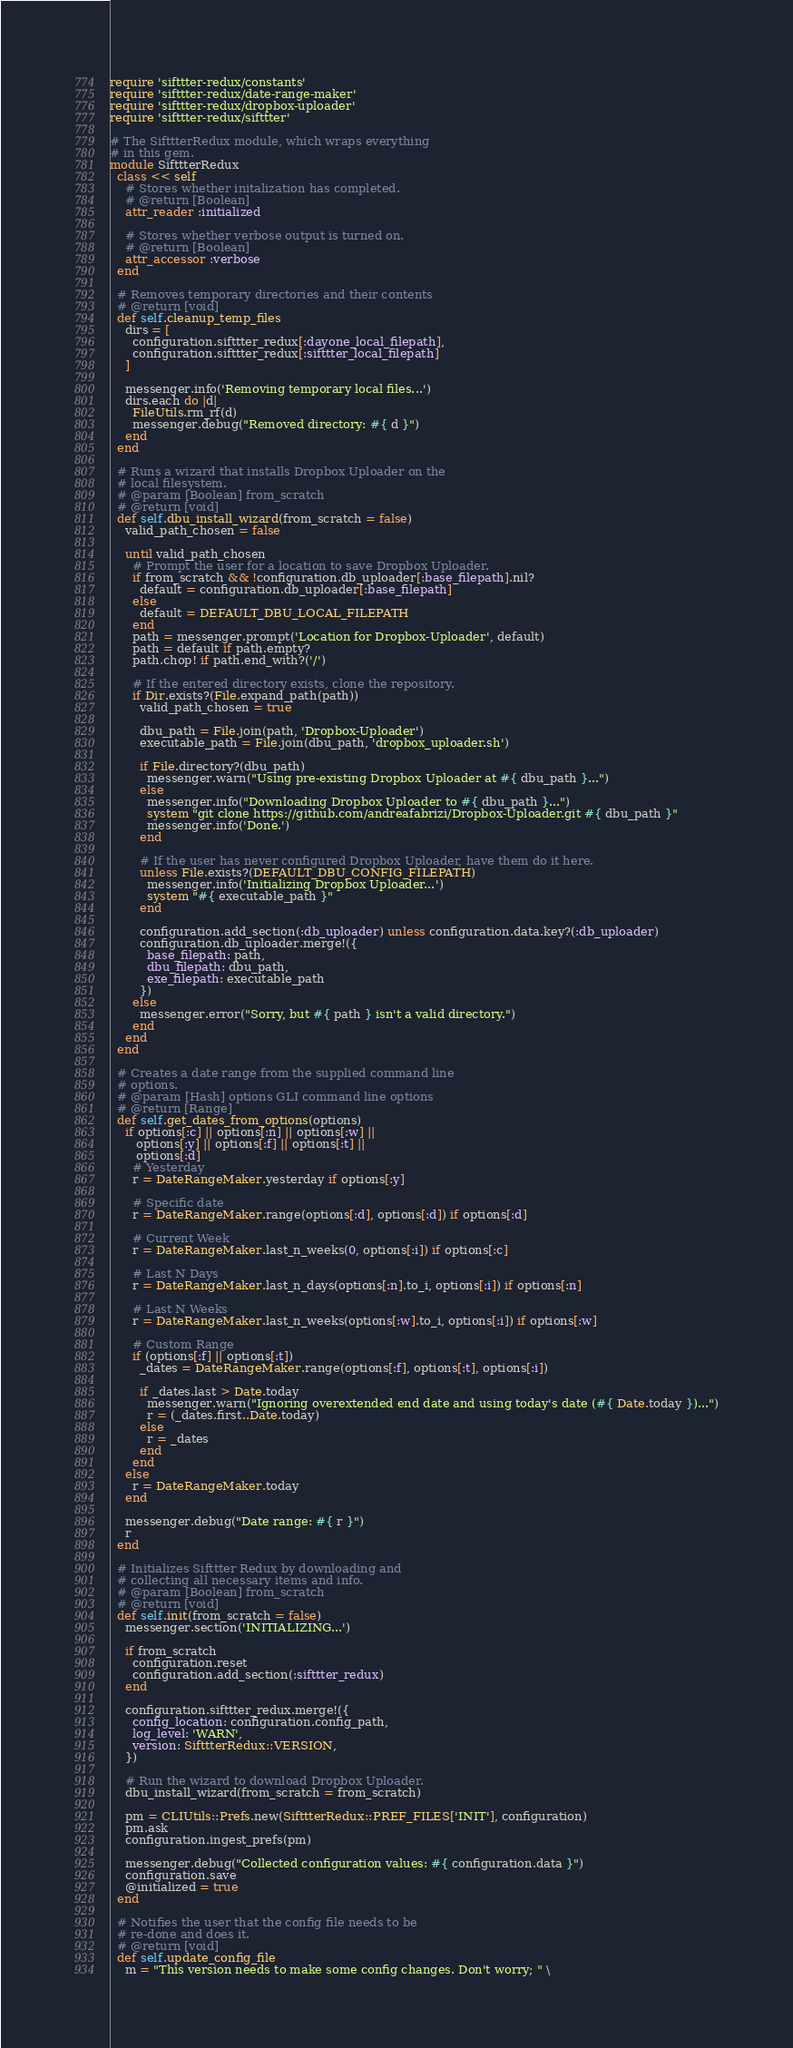<code> <loc_0><loc_0><loc_500><loc_500><_Ruby_>require 'sifttter-redux/constants'
require 'sifttter-redux/date-range-maker'
require 'sifttter-redux/dropbox-uploader'
require 'sifttter-redux/sifttter'

# The SifttterRedux module, which wraps everything
# in this gem.
module SifttterRedux
  class << self
    # Stores whether initalization has completed.
    # @return [Boolean]
    attr_reader :initialized

    # Stores whether verbose output is turned on.
    # @return [Boolean]
    attr_accessor :verbose
  end

  # Removes temporary directories and their contents
  # @return [void]
  def self.cleanup_temp_files
    dirs = [
      configuration.sifttter_redux[:dayone_local_filepath],
      configuration.sifttter_redux[:sifttter_local_filepath]
    ]

    messenger.info('Removing temporary local files...')
    dirs.each do |d|
      FileUtils.rm_rf(d)
      messenger.debug("Removed directory: #{ d }")
    end
  end

  # Runs a wizard that installs Dropbox Uploader on the
  # local filesystem.
  # @param [Boolean] from_scratch
  # @return [void]
  def self.dbu_install_wizard(from_scratch = false)
    valid_path_chosen = false

    until valid_path_chosen
      # Prompt the user for a location to save Dropbox Uploader.
      if from_scratch && !configuration.db_uploader[:base_filepath].nil?
        default = configuration.db_uploader[:base_filepath]
      else
        default = DEFAULT_DBU_LOCAL_FILEPATH
      end
      path = messenger.prompt('Location for Dropbox-Uploader', default)
      path = default if path.empty?
      path.chop! if path.end_with?('/')

      # If the entered directory exists, clone the repository.
      if Dir.exists?(File.expand_path(path))
        valid_path_chosen = true

        dbu_path = File.join(path, 'Dropbox-Uploader')
        executable_path = File.join(dbu_path, 'dropbox_uploader.sh')

        if File.directory?(dbu_path)
          messenger.warn("Using pre-existing Dropbox Uploader at #{ dbu_path }...")
        else
          messenger.info("Downloading Dropbox Uploader to #{ dbu_path }...")
          system "git clone https://github.com/andreafabrizi/Dropbox-Uploader.git #{ dbu_path }"
          messenger.info('Done.')
        end

        # If the user has never configured Dropbox Uploader, have them do it here.
        unless File.exists?(DEFAULT_DBU_CONFIG_FILEPATH)
          messenger.info('Initializing Dropbox Uploader...')
          system "#{ executable_path }"
        end

        configuration.add_section(:db_uploader) unless configuration.data.key?(:db_uploader)
        configuration.db_uploader.merge!({
          base_filepath: path,
          dbu_filepath: dbu_path,
          exe_filepath: executable_path
        })
      else
        messenger.error("Sorry, but #{ path } isn't a valid directory.")
      end
    end
  end

  # Creates a date range from the supplied command line
  # options.
  # @param [Hash] options GLI command line options
  # @return [Range]
  def self.get_dates_from_options(options)
    if options[:c] || options[:n] || options[:w] ||
       options[:y] || options[:f] || options[:t] ||
       options[:d]
      # Yesterday
      r = DateRangeMaker.yesterday if options[:y]

      # Specific date
      r = DateRangeMaker.range(options[:d], options[:d]) if options[:d]

      # Current Week
      r = DateRangeMaker.last_n_weeks(0, options[:i]) if options[:c]

      # Last N Days
      r = DateRangeMaker.last_n_days(options[:n].to_i, options[:i]) if options[:n]

      # Last N Weeks
      r = DateRangeMaker.last_n_weeks(options[:w].to_i, options[:i]) if options[:w]

      # Custom Range
      if (options[:f] || options[:t])
        _dates = DateRangeMaker.range(options[:f], options[:t], options[:i])

        if _dates.last > Date.today
          messenger.warn("Ignoring overextended end date and using today's date (#{ Date.today })...")
          r = (_dates.first..Date.today)
        else
          r = _dates
        end
      end
    else
      r = DateRangeMaker.today
    end

    messenger.debug("Date range: #{ r }")
    r
  end

  # Initializes Sifttter Redux by downloading and
  # collecting all necessary items and info.
  # @param [Boolean] from_scratch
  # @return [void]
  def self.init(from_scratch = false)
    messenger.section('INITIALIZING...')

    if from_scratch
      configuration.reset
      configuration.add_section(:sifttter_redux)
    end

    configuration.sifttter_redux.merge!({
      config_location: configuration.config_path,
      log_level: 'WARN',
      version: SifttterRedux::VERSION,
    })

    # Run the wizard to download Dropbox Uploader.
    dbu_install_wizard(from_scratch = from_scratch)

    pm = CLIUtils::Prefs.new(SifttterRedux::PREF_FILES['INIT'], configuration)
    pm.ask
    configuration.ingest_prefs(pm)

    messenger.debug("Collected configuration values: #{ configuration.data }")
    configuration.save
    @initialized = true
  end

  # Notifies the user that the config file needs to be
  # re-done and does it.
  # @return [void]
  def self.update_config_file
    m = "This version needs to make some config changes. Don't worry; " \</code> 